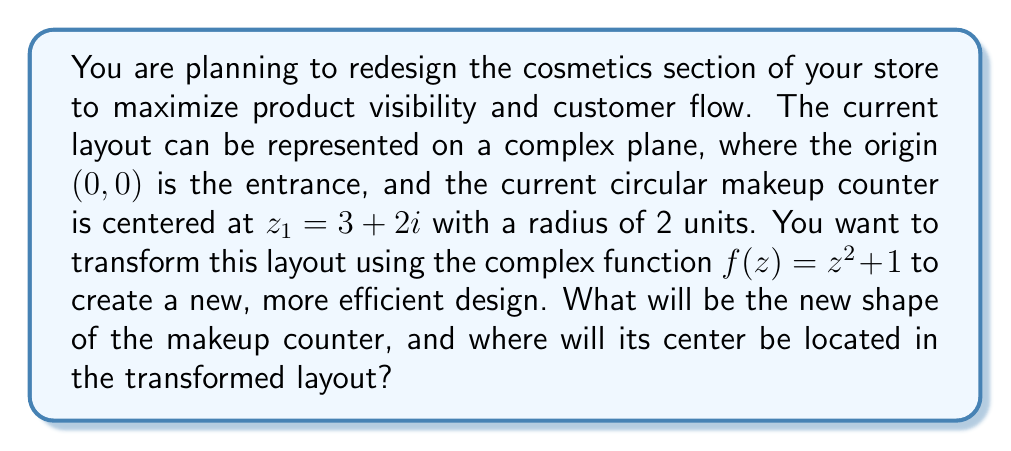Show me your answer to this math problem. To solve this problem, we need to apply the given complex transformation $f(z) = z^2 + 1$ to the circular makeup counter. Let's break it down step by step:

1) The original makeup counter is a circle with center $z_1 = 3 + 2i$ and radius 2.

2) To find the new shape, we need to consider how this transformation affects circles in general. The function $f(z) = z^2 + 1$ is a quadratic transformation, which typically transforms circles into more complex shapes called limacon curves.

3) To find the center of the new shape, we apply the transformation to the original center:

   $f(z_1) = (3 + 2i)^2 + 1$
   
   $= (9 - 4 + 12i) + 1$
   
   $= 6 + 12i$

4) The new shape will no longer be a perfect circle. It will be a limacon, which is a heart-shaped or kidney-shaped curve.

5) The size and exact shape of the limacon depend on the original circle's position relative to the origin. In this case, since the original circle doesn't contain the origin, the transformed shape will be a dimpled limacon (heart-shaped).

6) The transformation $z^2$ doubles angles from the origin and squares distances. The +1 term then shifts the entire shape one unit to the right.

7) While we can't easily describe the exact equation of the limacon boundary without using parametric equations, we can say that it will be approximately centered at the transformed center point (6, 12) in the complex plane.

This transformation creates a more dynamic and interesting shape for the makeup counter, potentially allowing for better product display and customer flow around its curves.

[asy]
import graph;
size(200);
 
// Original circle
draw(circle((3,2),2), blue);
dot((3,2), blue);
label("Original", (3,2), NE, blue);

// Transformed shape (approximated)
path heart = (8,12)..(7,14)..(6,15)..(5,14)..(4,12)..(5,10)..(6,9)..(7,10)..cycle;
draw(heart, red);
dot((6,12), red);
label("Transformed", (6,12), SE, red);

// Axes
xaxis("Re(z)", arrow=Arrow);
yaxis("Im(z)", arrow=Arrow);

label("0", (0,0), SW);
[/asy]
Answer: The new shape of the makeup counter will be a dimpled limacon (heart-shaped curve), approximately centered at $6 + 12i$ in the complex plane. 